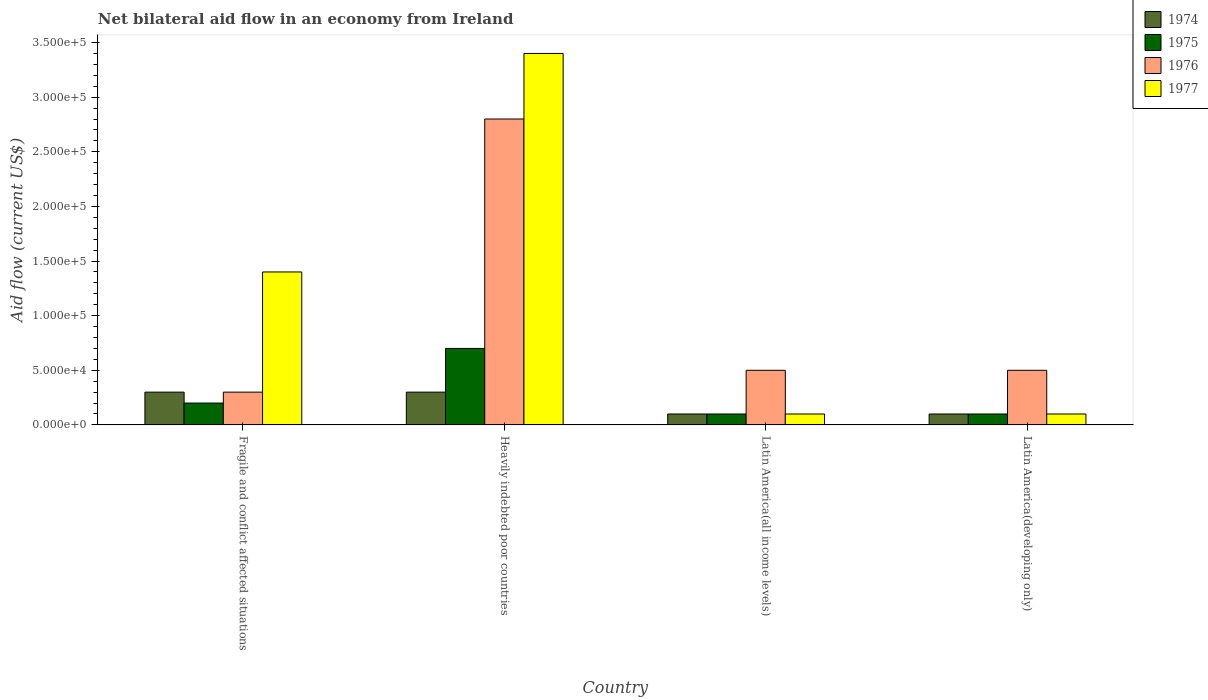Are the number of bars on each tick of the X-axis equal?
Your answer should be compact. Yes. How many bars are there on the 4th tick from the left?
Give a very brief answer. 4. How many bars are there on the 3rd tick from the right?
Provide a succinct answer. 4. What is the label of the 1st group of bars from the left?
Keep it short and to the point. Fragile and conflict affected situations. What is the net bilateral aid flow in 1975 in Latin America(all income levels)?
Give a very brief answer. 10000. Across all countries, what is the maximum net bilateral aid flow in 1974?
Give a very brief answer. 3.00e+04. Across all countries, what is the minimum net bilateral aid flow in 1975?
Your answer should be very brief. 10000. In which country was the net bilateral aid flow in 1977 maximum?
Keep it short and to the point. Heavily indebted poor countries. In which country was the net bilateral aid flow in 1974 minimum?
Your response must be concise. Latin America(all income levels). What is the difference between the net bilateral aid flow in 1977 in Fragile and conflict affected situations and that in Latin America(developing only)?
Ensure brevity in your answer.  1.30e+05. What is the average net bilateral aid flow in 1977 per country?
Provide a succinct answer. 1.25e+05. What is the difference between the net bilateral aid flow of/in 1975 and net bilateral aid flow of/in 1976 in Heavily indebted poor countries?
Offer a very short reply. -2.10e+05. In how many countries, is the net bilateral aid flow in 1976 greater than 160000 US$?
Give a very brief answer. 1. What is the difference between the highest and the lowest net bilateral aid flow in 1974?
Keep it short and to the point. 2.00e+04. In how many countries, is the net bilateral aid flow in 1975 greater than the average net bilateral aid flow in 1975 taken over all countries?
Provide a short and direct response. 1. Is it the case that in every country, the sum of the net bilateral aid flow in 1977 and net bilateral aid flow in 1976 is greater than the sum of net bilateral aid flow in 1974 and net bilateral aid flow in 1975?
Keep it short and to the point. No. What does the 3rd bar from the left in Heavily indebted poor countries represents?
Your response must be concise. 1976. What does the 3rd bar from the right in Heavily indebted poor countries represents?
Your answer should be very brief. 1975. Is it the case that in every country, the sum of the net bilateral aid flow in 1974 and net bilateral aid flow in 1976 is greater than the net bilateral aid flow in 1975?
Provide a succinct answer. Yes. Are all the bars in the graph horizontal?
Your answer should be compact. No. How many countries are there in the graph?
Offer a terse response. 4. Does the graph contain any zero values?
Provide a succinct answer. No. Where does the legend appear in the graph?
Your answer should be compact. Top right. What is the title of the graph?
Your answer should be very brief. Net bilateral aid flow in an economy from Ireland. Does "1970" appear as one of the legend labels in the graph?
Give a very brief answer. No. What is the label or title of the X-axis?
Make the answer very short. Country. What is the Aid flow (current US$) of 1976 in Fragile and conflict affected situations?
Keep it short and to the point. 3.00e+04. What is the Aid flow (current US$) of 1977 in Fragile and conflict affected situations?
Ensure brevity in your answer.  1.40e+05. What is the Aid flow (current US$) in 1976 in Heavily indebted poor countries?
Give a very brief answer. 2.80e+05. What is the Aid flow (current US$) of 1975 in Latin America(all income levels)?
Your answer should be compact. 10000. What is the Aid flow (current US$) in 1976 in Latin America(all income levels)?
Your response must be concise. 5.00e+04. What is the Aid flow (current US$) of 1977 in Latin America(all income levels)?
Provide a succinct answer. 10000. What is the Aid flow (current US$) of 1974 in Latin America(developing only)?
Ensure brevity in your answer.  10000. Across all countries, what is the maximum Aid flow (current US$) in 1974?
Your response must be concise. 3.00e+04. Across all countries, what is the maximum Aid flow (current US$) of 1975?
Offer a very short reply. 7.00e+04. Across all countries, what is the maximum Aid flow (current US$) in 1976?
Your answer should be very brief. 2.80e+05. Across all countries, what is the maximum Aid flow (current US$) of 1977?
Your answer should be very brief. 3.40e+05. Across all countries, what is the minimum Aid flow (current US$) in 1974?
Your answer should be compact. 10000. Across all countries, what is the minimum Aid flow (current US$) of 1975?
Provide a short and direct response. 10000. Across all countries, what is the minimum Aid flow (current US$) of 1976?
Make the answer very short. 3.00e+04. Across all countries, what is the minimum Aid flow (current US$) in 1977?
Offer a very short reply. 10000. What is the total Aid flow (current US$) of 1974 in the graph?
Make the answer very short. 8.00e+04. What is the total Aid flow (current US$) in 1977 in the graph?
Provide a succinct answer. 5.00e+05. What is the difference between the Aid flow (current US$) in 1975 in Fragile and conflict affected situations and that in Heavily indebted poor countries?
Your answer should be compact. -5.00e+04. What is the difference between the Aid flow (current US$) of 1977 in Fragile and conflict affected situations and that in Heavily indebted poor countries?
Provide a succinct answer. -2.00e+05. What is the difference between the Aid flow (current US$) in 1976 in Fragile and conflict affected situations and that in Latin America(all income levels)?
Provide a short and direct response. -2.00e+04. What is the difference between the Aid flow (current US$) of 1974 in Fragile and conflict affected situations and that in Latin America(developing only)?
Provide a succinct answer. 2.00e+04. What is the difference between the Aid flow (current US$) in 1975 in Fragile and conflict affected situations and that in Latin America(developing only)?
Give a very brief answer. 10000. What is the difference between the Aid flow (current US$) of 1977 in Fragile and conflict affected situations and that in Latin America(developing only)?
Provide a short and direct response. 1.30e+05. What is the difference between the Aid flow (current US$) of 1976 in Heavily indebted poor countries and that in Latin America(all income levels)?
Provide a short and direct response. 2.30e+05. What is the difference between the Aid flow (current US$) in 1974 in Heavily indebted poor countries and that in Latin America(developing only)?
Provide a succinct answer. 2.00e+04. What is the difference between the Aid flow (current US$) of 1975 in Heavily indebted poor countries and that in Latin America(developing only)?
Your answer should be compact. 6.00e+04. What is the difference between the Aid flow (current US$) of 1974 in Latin America(all income levels) and that in Latin America(developing only)?
Your answer should be compact. 0. What is the difference between the Aid flow (current US$) of 1975 in Latin America(all income levels) and that in Latin America(developing only)?
Give a very brief answer. 0. What is the difference between the Aid flow (current US$) of 1974 in Fragile and conflict affected situations and the Aid flow (current US$) of 1975 in Heavily indebted poor countries?
Give a very brief answer. -4.00e+04. What is the difference between the Aid flow (current US$) in 1974 in Fragile and conflict affected situations and the Aid flow (current US$) in 1977 in Heavily indebted poor countries?
Keep it short and to the point. -3.10e+05. What is the difference between the Aid flow (current US$) in 1975 in Fragile and conflict affected situations and the Aid flow (current US$) in 1977 in Heavily indebted poor countries?
Give a very brief answer. -3.20e+05. What is the difference between the Aid flow (current US$) in 1976 in Fragile and conflict affected situations and the Aid flow (current US$) in 1977 in Heavily indebted poor countries?
Ensure brevity in your answer.  -3.10e+05. What is the difference between the Aid flow (current US$) in 1974 in Fragile and conflict affected situations and the Aid flow (current US$) in 1975 in Latin America(all income levels)?
Your response must be concise. 2.00e+04. What is the difference between the Aid flow (current US$) in 1974 in Fragile and conflict affected situations and the Aid flow (current US$) in 1976 in Latin America(all income levels)?
Offer a very short reply. -2.00e+04. What is the difference between the Aid flow (current US$) in 1974 in Fragile and conflict affected situations and the Aid flow (current US$) in 1977 in Latin America(all income levels)?
Ensure brevity in your answer.  2.00e+04. What is the difference between the Aid flow (current US$) of 1975 in Fragile and conflict affected situations and the Aid flow (current US$) of 1976 in Latin America(all income levels)?
Offer a terse response. -3.00e+04. What is the difference between the Aid flow (current US$) of 1975 in Fragile and conflict affected situations and the Aid flow (current US$) of 1977 in Latin America(all income levels)?
Provide a succinct answer. 10000. What is the difference between the Aid flow (current US$) in 1975 in Fragile and conflict affected situations and the Aid flow (current US$) in 1976 in Latin America(developing only)?
Offer a very short reply. -3.00e+04. What is the difference between the Aid flow (current US$) in 1975 in Heavily indebted poor countries and the Aid flow (current US$) in 1976 in Latin America(all income levels)?
Provide a short and direct response. 2.00e+04. What is the difference between the Aid flow (current US$) in 1976 in Heavily indebted poor countries and the Aid flow (current US$) in 1977 in Latin America(all income levels)?
Your answer should be very brief. 2.70e+05. What is the difference between the Aid flow (current US$) of 1974 in Heavily indebted poor countries and the Aid flow (current US$) of 1976 in Latin America(developing only)?
Provide a short and direct response. -2.00e+04. What is the difference between the Aid flow (current US$) in 1976 in Heavily indebted poor countries and the Aid flow (current US$) in 1977 in Latin America(developing only)?
Your response must be concise. 2.70e+05. What is the difference between the Aid flow (current US$) in 1975 in Latin America(all income levels) and the Aid flow (current US$) in 1977 in Latin America(developing only)?
Provide a short and direct response. 0. What is the average Aid flow (current US$) of 1975 per country?
Offer a very short reply. 2.75e+04. What is the average Aid flow (current US$) in 1976 per country?
Offer a terse response. 1.02e+05. What is the average Aid flow (current US$) of 1977 per country?
Offer a terse response. 1.25e+05. What is the difference between the Aid flow (current US$) of 1974 and Aid flow (current US$) of 1975 in Fragile and conflict affected situations?
Your answer should be compact. 10000. What is the difference between the Aid flow (current US$) in 1974 and Aid flow (current US$) in 1976 in Fragile and conflict affected situations?
Your answer should be compact. 0. What is the difference between the Aid flow (current US$) in 1975 and Aid flow (current US$) in 1976 in Fragile and conflict affected situations?
Provide a succinct answer. -10000. What is the difference between the Aid flow (current US$) in 1974 and Aid flow (current US$) in 1975 in Heavily indebted poor countries?
Your answer should be very brief. -4.00e+04. What is the difference between the Aid flow (current US$) in 1974 and Aid flow (current US$) in 1977 in Heavily indebted poor countries?
Your answer should be very brief. -3.10e+05. What is the difference between the Aid flow (current US$) in 1975 and Aid flow (current US$) in 1977 in Heavily indebted poor countries?
Your answer should be very brief. -2.70e+05. What is the difference between the Aid flow (current US$) of 1976 and Aid flow (current US$) of 1977 in Heavily indebted poor countries?
Ensure brevity in your answer.  -6.00e+04. What is the difference between the Aid flow (current US$) of 1975 and Aid flow (current US$) of 1976 in Latin America(all income levels)?
Provide a short and direct response. -4.00e+04. What is the difference between the Aid flow (current US$) of 1974 and Aid flow (current US$) of 1976 in Latin America(developing only)?
Your answer should be compact. -4.00e+04. What is the difference between the Aid flow (current US$) of 1974 and Aid flow (current US$) of 1977 in Latin America(developing only)?
Ensure brevity in your answer.  0. What is the difference between the Aid flow (current US$) of 1975 and Aid flow (current US$) of 1976 in Latin America(developing only)?
Your answer should be very brief. -4.00e+04. What is the difference between the Aid flow (current US$) in 1975 and Aid flow (current US$) in 1977 in Latin America(developing only)?
Give a very brief answer. 0. What is the difference between the Aid flow (current US$) of 1976 and Aid flow (current US$) of 1977 in Latin America(developing only)?
Offer a terse response. 4.00e+04. What is the ratio of the Aid flow (current US$) of 1975 in Fragile and conflict affected situations to that in Heavily indebted poor countries?
Your answer should be compact. 0.29. What is the ratio of the Aid flow (current US$) in 1976 in Fragile and conflict affected situations to that in Heavily indebted poor countries?
Offer a very short reply. 0.11. What is the ratio of the Aid flow (current US$) in 1977 in Fragile and conflict affected situations to that in Heavily indebted poor countries?
Keep it short and to the point. 0.41. What is the ratio of the Aid flow (current US$) in 1976 in Fragile and conflict affected situations to that in Latin America(all income levels)?
Your answer should be compact. 0.6. What is the ratio of the Aid flow (current US$) in 1975 in Fragile and conflict affected situations to that in Latin America(developing only)?
Your response must be concise. 2. What is the ratio of the Aid flow (current US$) in 1976 in Fragile and conflict affected situations to that in Latin America(developing only)?
Keep it short and to the point. 0.6. What is the ratio of the Aid flow (current US$) of 1977 in Fragile and conflict affected situations to that in Latin America(developing only)?
Ensure brevity in your answer.  14. What is the ratio of the Aid flow (current US$) in 1976 in Heavily indebted poor countries to that in Latin America(all income levels)?
Your answer should be compact. 5.6. What is the ratio of the Aid flow (current US$) in 1977 in Heavily indebted poor countries to that in Latin America(developing only)?
Make the answer very short. 34. What is the ratio of the Aid flow (current US$) of 1975 in Latin America(all income levels) to that in Latin America(developing only)?
Your answer should be very brief. 1. What is the ratio of the Aid flow (current US$) in 1977 in Latin America(all income levels) to that in Latin America(developing only)?
Your answer should be very brief. 1. What is the difference between the highest and the second highest Aid flow (current US$) in 1974?
Your response must be concise. 0. What is the difference between the highest and the second highest Aid flow (current US$) of 1975?
Ensure brevity in your answer.  5.00e+04. What is the difference between the highest and the second highest Aid flow (current US$) in 1976?
Make the answer very short. 2.30e+05. What is the difference between the highest and the lowest Aid flow (current US$) of 1974?
Ensure brevity in your answer.  2.00e+04. What is the difference between the highest and the lowest Aid flow (current US$) of 1976?
Offer a terse response. 2.50e+05. What is the difference between the highest and the lowest Aid flow (current US$) of 1977?
Offer a very short reply. 3.30e+05. 